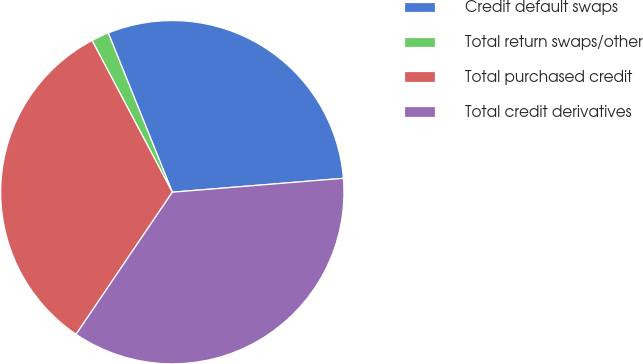Convert chart. <chart><loc_0><loc_0><loc_500><loc_500><pie_chart><fcel>Credit default swaps<fcel>Total return swaps/other<fcel>Total purchased credit<fcel>Total credit derivatives<nl><fcel>29.8%<fcel>1.66%<fcel>32.78%<fcel>35.76%<nl></chart> 